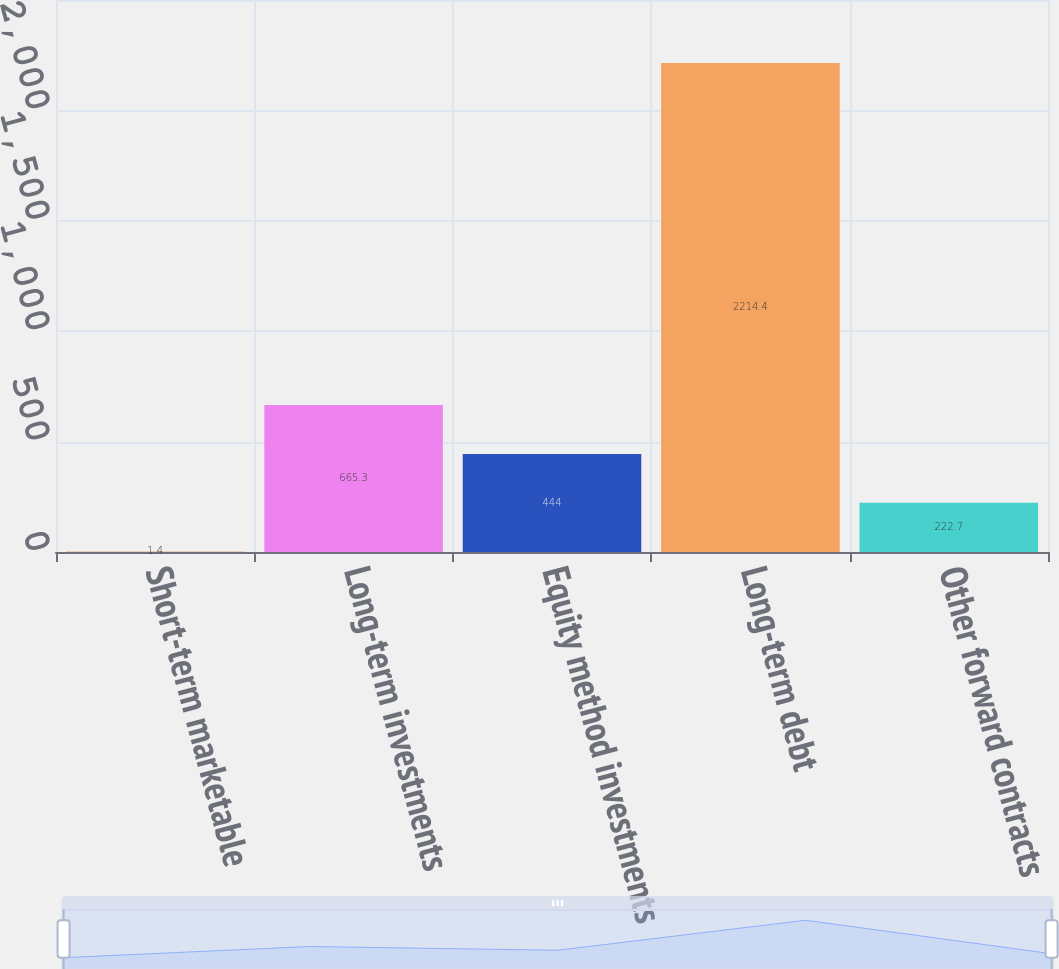Convert chart to OTSL. <chart><loc_0><loc_0><loc_500><loc_500><bar_chart><fcel>Short-term marketable<fcel>Long-term investments<fcel>Equity method investments<fcel>Long-term debt<fcel>Other forward contracts<nl><fcel>1.4<fcel>665.3<fcel>444<fcel>2214.4<fcel>222.7<nl></chart> 